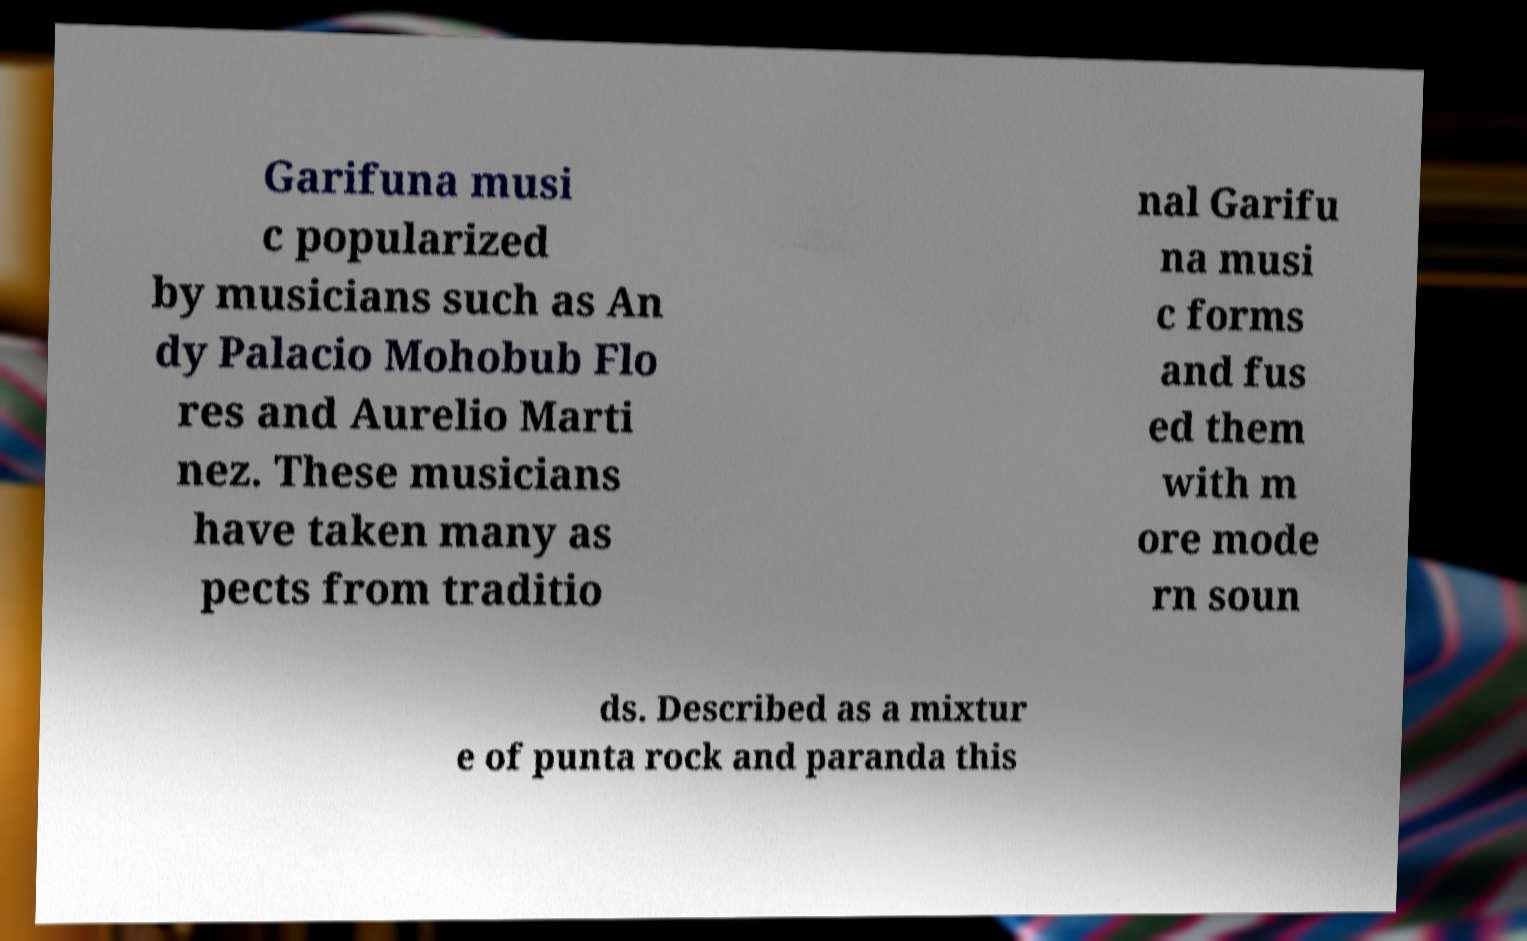There's text embedded in this image that I need extracted. Can you transcribe it verbatim? Garifuna musi c popularized by musicians such as An dy Palacio Mohobub Flo res and Aurelio Marti nez. These musicians have taken many as pects from traditio nal Garifu na musi c forms and fus ed them with m ore mode rn soun ds. Described as a mixtur e of punta rock and paranda this 